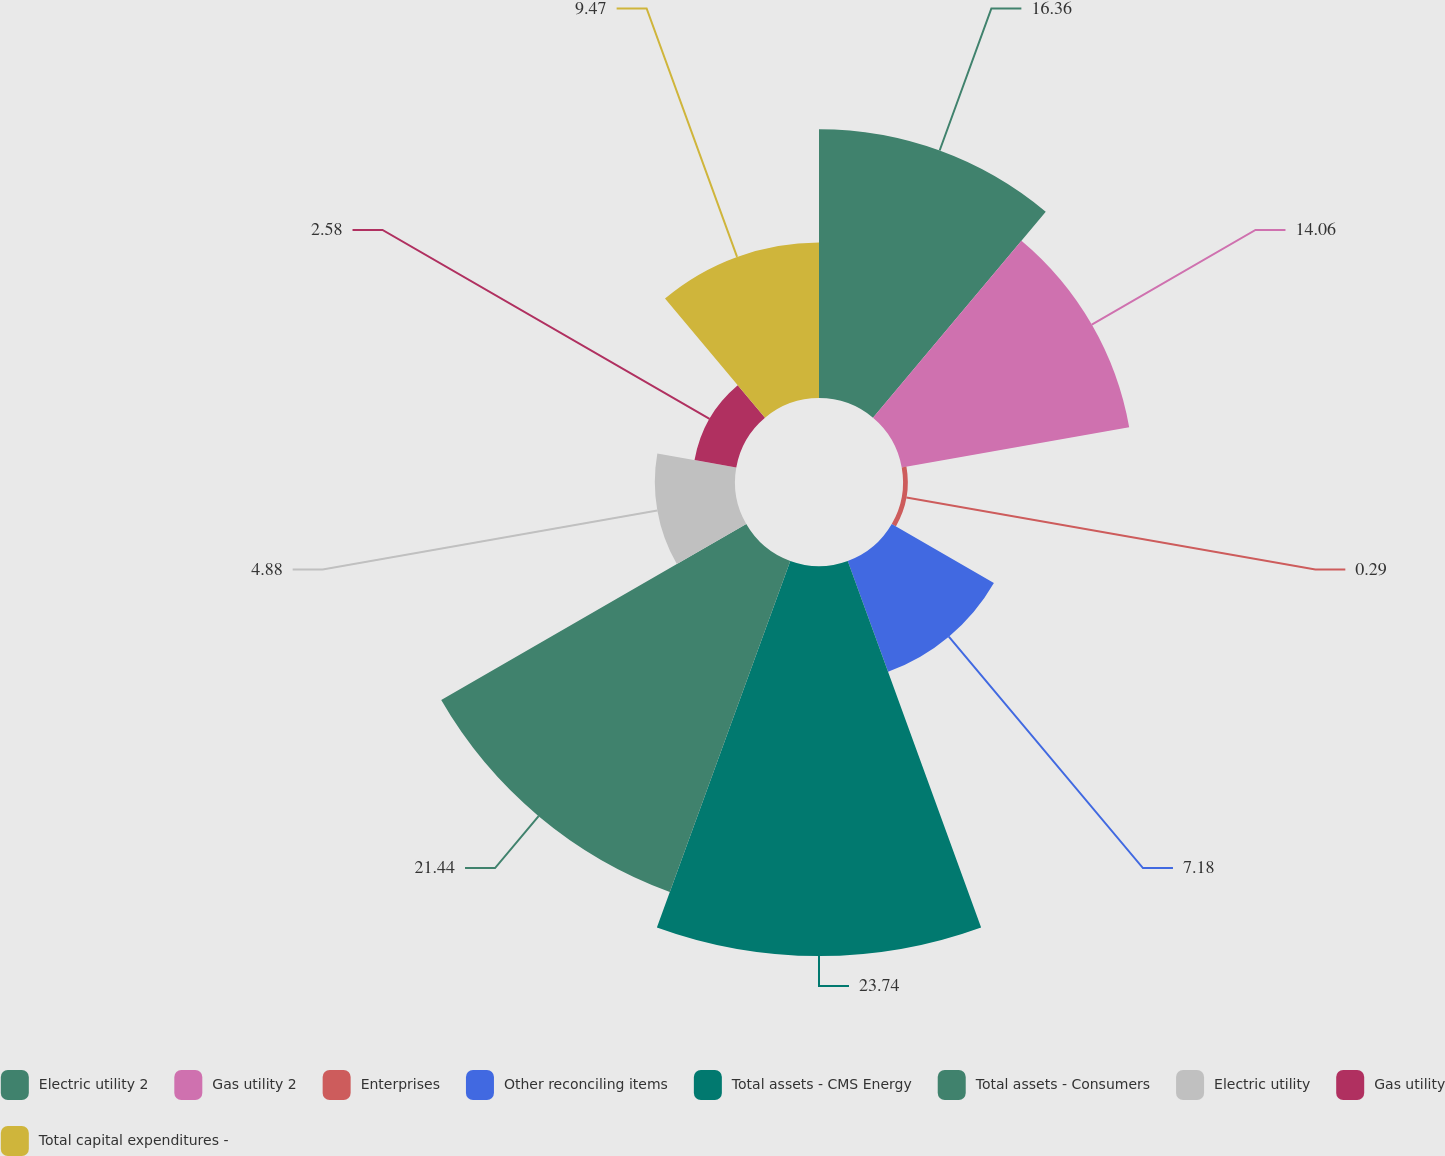Convert chart to OTSL. <chart><loc_0><loc_0><loc_500><loc_500><pie_chart><fcel>Electric utility 2<fcel>Gas utility 2<fcel>Enterprises<fcel>Other reconciling items<fcel>Total assets - CMS Energy<fcel>Total assets - Consumers<fcel>Electric utility<fcel>Gas utility<fcel>Total capital expenditures -<nl><fcel>16.36%<fcel>14.06%<fcel>0.29%<fcel>7.18%<fcel>23.74%<fcel>21.44%<fcel>4.88%<fcel>2.58%<fcel>9.47%<nl></chart> 